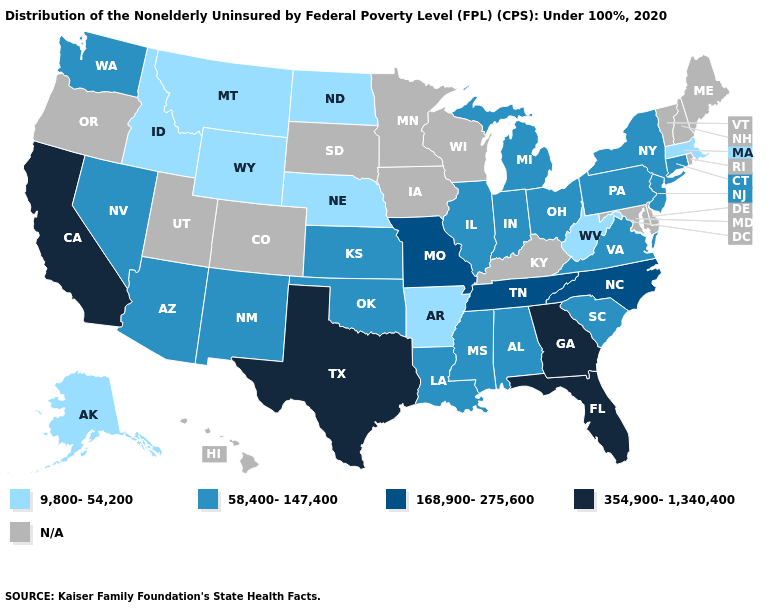Which states have the lowest value in the Northeast?
Short answer required. Massachusetts. How many symbols are there in the legend?
Write a very short answer. 5. What is the highest value in states that border Oregon?
Answer briefly. 354,900-1,340,400. What is the value of Alabama?
Keep it brief. 58,400-147,400. Does the first symbol in the legend represent the smallest category?
Answer briefly. Yes. Which states have the lowest value in the USA?
Keep it brief. Alaska, Arkansas, Idaho, Massachusetts, Montana, Nebraska, North Dakota, West Virginia, Wyoming. Name the states that have a value in the range 168,900-275,600?
Concise answer only. Missouri, North Carolina, Tennessee. What is the lowest value in the USA?
Give a very brief answer. 9,800-54,200. Name the states that have a value in the range 9,800-54,200?
Write a very short answer. Alaska, Arkansas, Idaho, Massachusetts, Montana, Nebraska, North Dakota, West Virginia, Wyoming. Does Ohio have the lowest value in the MidWest?
Quick response, please. No. What is the value of Illinois?
Short answer required. 58,400-147,400. Which states hav the highest value in the MidWest?
Give a very brief answer. Missouri. What is the value of Florida?
Quick response, please. 354,900-1,340,400. Name the states that have a value in the range 58,400-147,400?
Write a very short answer. Alabama, Arizona, Connecticut, Illinois, Indiana, Kansas, Louisiana, Michigan, Mississippi, Nevada, New Jersey, New Mexico, New York, Ohio, Oklahoma, Pennsylvania, South Carolina, Virginia, Washington. 